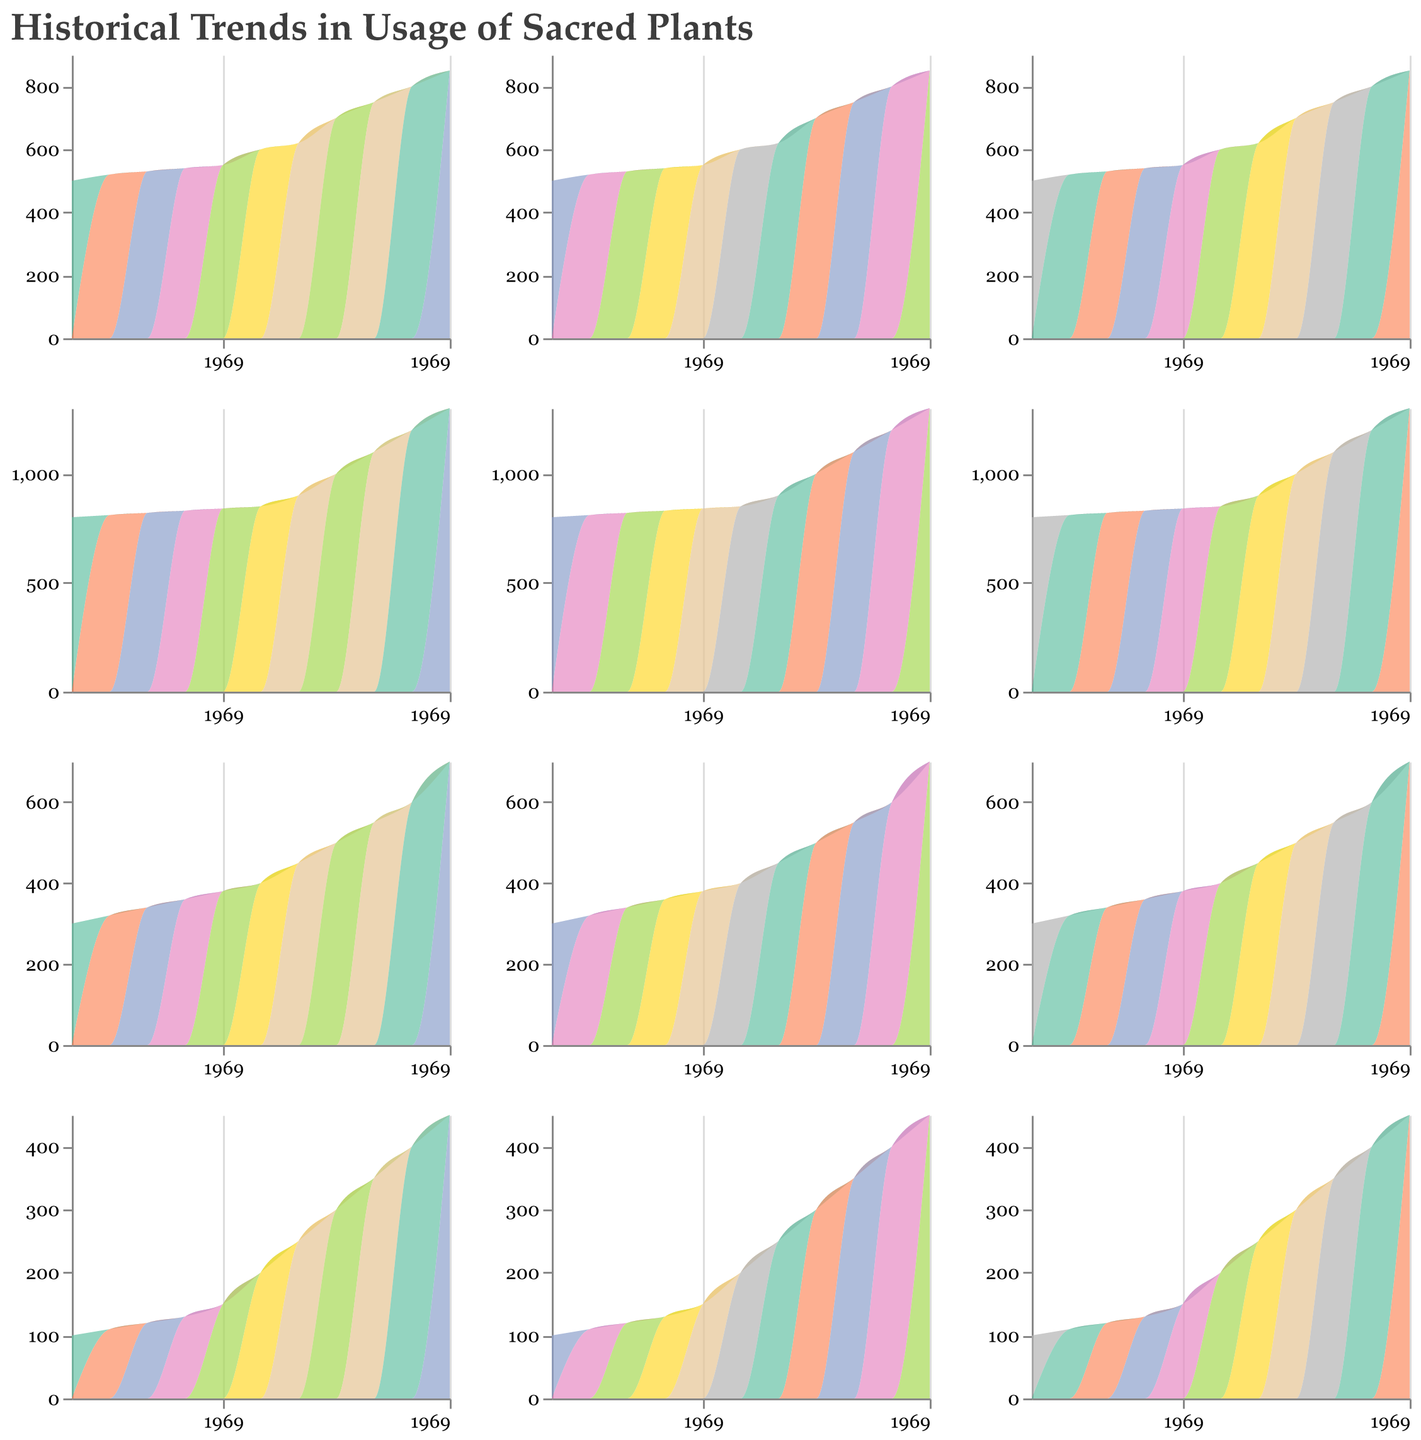Which sacred plant had the highest usage in 2020? In 2020, by looking at the ending values of all the area charts, Peyote has the highest usage among all the sacred plants.
Answer: Peyote What is the trend in the usage of Ayahuasca from 1970 to 2020? By observing the area chart for Ayahuasca, we can see a steady increase in usage over the years, going from 500 in 1970 to 850 in 2020.
Answer: Steadily increasing Which sacred plant showed the most significant increase in usage between 1995 and 2000? To determine this, compare the differences in usage for all the plants between 1995 and 2000. Salvia Divinorum shows the largest increase, from 100 in 1995 to 150 in 2000, an increase of 50.
Answer: Salvia Divinorum How does the usage of Sage compare to the usage of Kava in the year 2015? By looking at the values for Sage and Kava in 2015, we see Sage at 600 and Kava at 400. Thus, Sage has a higher usage than Kava in 2015.
Answer: Sage What is the average usage of Tulsi between 1970 and 2020? To find the average usage of Tulsi, sum the values from each year and divide by the number of years. The values are 600, 620, 630, 640, 650, 660, 700, 750, 800, 850, 900. The sum is 8200, and dividing by 11 gives an average of approximately 745.45.
Answer: 745.45 Which plant shows the least fluctuation in its usage over time? By observing the consistency in the slopes of the area charts, Tulsi shows the least fluctuation, indicating a more consistent increase in usage over the years.
Answer: Tulsi In which year did San Pedro Cactus usage surpass 400? By finding the year where San Pedro Cactus crosses the 400 mark in its area chart, it is apparent that it surpassed 400 for the first time in 2005.
Answer: 2005 Identify the range of usage values for Kava from 1970 to 2020. Observing the minimum and maximum values of the Kava area chart, its usage starts at 100 in 1970 and reaches 450 in 2020, giving a range of 100 to 450.
Answer: 100 to 450 Which two plants show the most similar trends in their usage over time? By comparing the slopes and trends of the area charts, Ayahuasca and Kava show the most similar trends, both consistently increasing over time with relatively similar patterns of growth.
Answer: Ayahuasca and Kava During which years did Ayahuasca experience the steepest increase in usage? To determine this, find the years where Ayahuasca's increase is the most pronounced. The sharpest increase happens between 1995 (600) and 2005 (700).
Answer: 1995 - 2005 